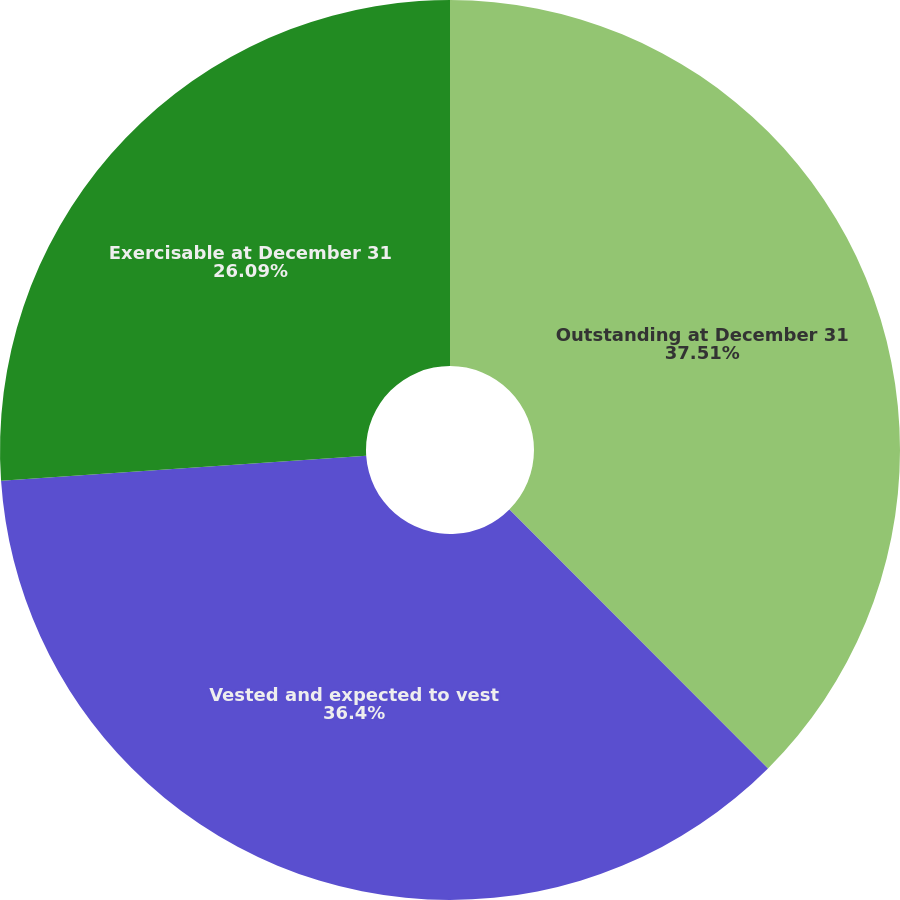Convert chart to OTSL. <chart><loc_0><loc_0><loc_500><loc_500><pie_chart><fcel>Outstanding at December 31<fcel>Vested and expected to vest<fcel>Exercisable at December 31<nl><fcel>37.51%<fcel>36.4%<fcel>26.09%<nl></chart> 